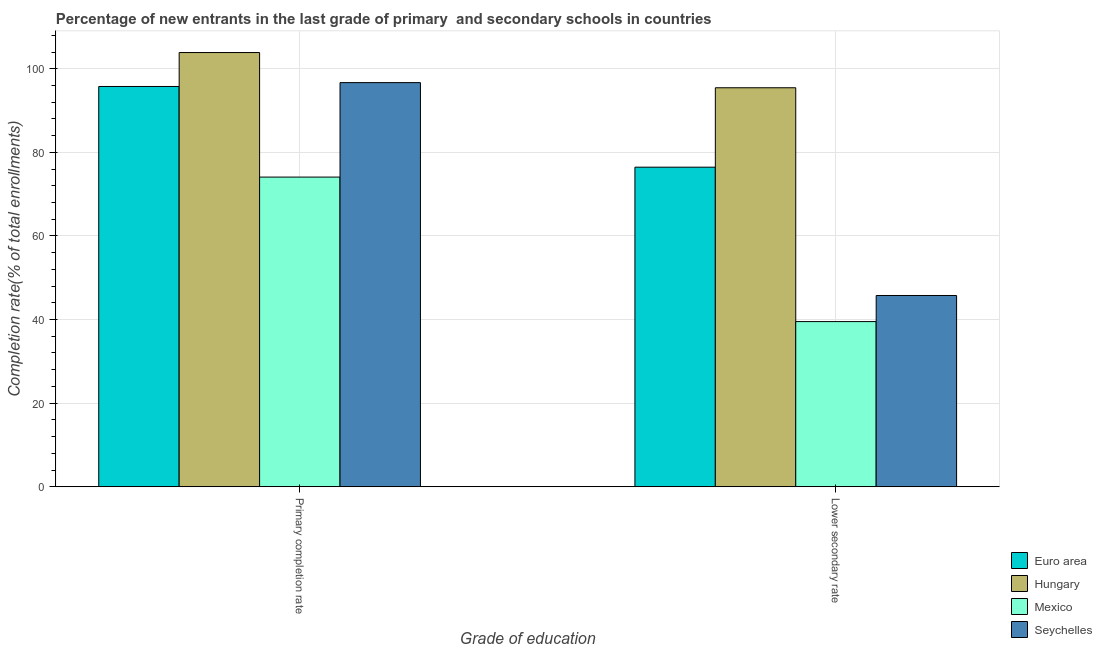How many different coloured bars are there?
Make the answer very short. 4. How many groups of bars are there?
Offer a very short reply. 2. Are the number of bars per tick equal to the number of legend labels?
Your response must be concise. Yes. Are the number of bars on each tick of the X-axis equal?
Make the answer very short. Yes. What is the label of the 1st group of bars from the left?
Your answer should be compact. Primary completion rate. What is the completion rate in secondary schools in Hungary?
Provide a succinct answer. 95.45. Across all countries, what is the maximum completion rate in primary schools?
Your response must be concise. 103.88. Across all countries, what is the minimum completion rate in primary schools?
Your answer should be compact. 74.08. In which country was the completion rate in primary schools maximum?
Give a very brief answer. Hungary. In which country was the completion rate in primary schools minimum?
Offer a terse response. Mexico. What is the total completion rate in primary schools in the graph?
Provide a short and direct response. 370.4. What is the difference between the completion rate in primary schools in Hungary and that in Seychelles?
Make the answer very short. 7.2. What is the difference between the completion rate in primary schools in Hungary and the completion rate in secondary schools in Seychelles?
Provide a short and direct response. 58.13. What is the average completion rate in primary schools per country?
Keep it short and to the point. 92.6. What is the difference between the completion rate in primary schools and completion rate in secondary schools in Mexico?
Your answer should be compact. 34.57. What is the ratio of the completion rate in secondary schools in Mexico to that in Hungary?
Give a very brief answer. 0.41. In how many countries, is the completion rate in primary schools greater than the average completion rate in primary schools taken over all countries?
Offer a very short reply. 3. What does the 4th bar from the left in Lower secondary rate represents?
Provide a short and direct response. Seychelles. What does the 2nd bar from the right in Lower secondary rate represents?
Make the answer very short. Mexico. How many bars are there?
Offer a terse response. 8. Are all the bars in the graph horizontal?
Your response must be concise. No. Does the graph contain grids?
Give a very brief answer. Yes. How are the legend labels stacked?
Your answer should be compact. Vertical. What is the title of the graph?
Ensure brevity in your answer.  Percentage of new entrants in the last grade of primary  and secondary schools in countries. What is the label or title of the X-axis?
Ensure brevity in your answer.  Grade of education. What is the label or title of the Y-axis?
Offer a terse response. Completion rate(% of total enrollments). What is the Completion rate(% of total enrollments) of Euro area in Primary completion rate?
Provide a succinct answer. 95.76. What is the Completion rate(% of total enrollments) in Hungary in Primary completion rate?
Your answer should be compact. 103.88. What is the Completion rate(% of total enrollments) in Mexico in Primary completion rate?
Your response must be concise. 74.08. What is the Completion rate(% of total enrollments) of Seychelles in Primary completion rate?
Give a very brief answer. 96.68. What is the Completion rate(% of total enrollments) of Euro area in Lower secondary rate?
Your answer should be very brief. 76.45. What is the Completion rate(% of total enrollments) in Hungary in Lower secondary rate?
Offer a very short reply. 95.45. What is the Completion rate(% of total enrollments) of Mexico in Lower secondary rate?
Offer a very short reply. 39.51. What is the Completion rate(% of total enrollments) in Seychelles in Lower secondary rate?
Your response must be concise. 45.75. Across all Grade of education, what is the maximum Completion rate(% of total enrollments) in Euro area?
Your answer should be compact. 95.76. Across all Grade of education, what is the maximum Completion rate(% of total enrollments) of Hungary?
Provide a succinct answer. 103.88. Across all Grade of education, what is the maximum Completion rate(% of total enrollments) of Mexico?
Ensure brevity in your answer.  74.08. Across all Grade of education, what is the maximum Completion rate(% of total enrollments) of Seychelles?
Your response must be concise. 96.68. Across all Grade of education, what is the minimum Completion rate(% of total enrollments) in Euro area?
Offer a very short reply. 76.45. Across all Grade of education, what is the minimum Completion rate(% of total enrollments) in Hungary?
Your answer should be compact. 95.45. Across all Grade of education, what is the minimum Completion rate(% of total enrollments) of Mexico?
Provide a succinct answer. 39.51. Across all Grade of education, what is the minimum Completion rate(% of total enrollments) in Seychelles?
Your response must be concise. 45.75. What is the total Completion rate(% of total enrollments) of Euro area in the graph?
Ensure brevity in your answer.  172.21. What is the total Completion rate(% of total enrollments) of Hungary in the graph?
Provide a short and direct response. 199.34. What is the total Completion rate(% of total enrollments) of Mexico in the graph?
Your response must be concise. 113.59. What is the total Completion rate(% of total enrollments) of Seychelles in the graph?
Your answer should be very brief. 142.44. What is the difference between the Completion rate(% of total enrollments) of Euro area in Primary completion rate and that in Lower secondary rate?
Your answer should be very brief. 19.31. What is the difference between the Completion rate(% of total enrollments) in Hungary in Primary completion rate and that in Lower secondary rate?
Ensure brevity in your answer.  8.43. What is the difference between the Completion rate(% of total enrollments) of Mexico in Primary completion rate and that in Lower secondary rate?
Give a very brief answer. 34.57. What is the difference between the Completion rate(% of total enrollments) in Seychelles in Primary completion rate and that in Lower secondary rate?
Provide a succinct answer. 50.93. What is the difference between the Completion rate(% of total enrollments) of Euro area in Primary completion rate and the Completion rate(% of total enrollments) of Hungary in Lower secondary rate?
Your answer should be very brief. 0.3. What is the difference between the Completion rate(% of total enrollments) in Euro area in Primary completion rate and the Completion rate(% of total enrollments) in Mexico in Lower secondary rate?
Your response must be concise. 56.25. What is the difference between the Completion rate(% of total enrollments) of Euro area in Primary completion rate and the Completion rate(% of total enrollments) of Seychelles in Lower secondary rate?
Give a very brief answer. 50.01. What is the difference between the Completion rate(% of total enrollments) in Hungary in Primary completion rate and the Completion rate(% of total enrollments) in Mexico in Lower secondary rate?
Your answer should be very brief. 64.37. What is the difference between the Completion rate(% of total enrollments) in Hungary in Primary completion rate and the Completion rate(% of total enrollments) in Seychelles in Lower secondary rate?
Offer a very short reply. 58.13. What is the difference between the Completion rate(% of total enrollments) in Mexico in Primary completion rate and the Completion rate(% of total enrollments) in Seychelles in Lower secondary rate?
Make the answer very short. 28.33. What is the average Completion rate(% of total enrollments) of Euro area per Grade of education?
Give a very brief answer. 86.11. What is the average Completion rate(% of total enrollments) of Hungary per Grade of education?
Give a very brief answer. 99.67. What is the average Completion rate(% of total enrollments) of Mexico per Grade of education?
Provide a succinct answer. 56.79. What is the average Completion rate(% of total enrollments) in Seychelles per Grade of education?
Your answer should be compact. 71.22. What is the difference between the Completion rate(% of total enrollments) in Euro area and Completion rate(% of total enrollments) in Hungary in Primary completion rate?
Your answer should be very brief. -8.12. What is the difference between the Completion rate(% of total enrollments) of Euro area and Completion rate(% of total enrollments) of Mexico in Primary completion rate?
Offer a very short reply. 21.68. What is the difference between the Completion rate(% of total enrollments) of Euro area and Completion rate(% of total enrollments) of Seychelles in Primary completion rate?
Your response must be concise. -0.92. What is the difference between the Completion rate(% of total enrollments) of Hungary and Completion rate(% of total enrollments) of Mexico in Primary completion rate?
Your answer should be very brief. 29.8. What is the difference between the Completion rate(% of total enrollments) in Hungary and Completion rate(% of total enrollments) in Seychelles in Primary completion rate?
Your answer should be very brief. 7.2. What is the difference between the Completion rate(% of total enrollments) in Mexico and Completion rate(% of total enrollments) in Seychelles in Primary completion rate?
Your response must be concise. -22.6. What is the difference between the Completion rate(% of total enrollments) of Euro area and Completion rate(% of total enrollments) of Hungary in Lower secondary rate?
Offer a very short reply. -19. What is the difference between the Completion rate(% of total enrollments) in Euro area and Completion rate(% of total enrollments) in Mexico in Lower secondary rate?
Your answer should be compact. 36.95. What is the difference between the Completion rate(% of total enrollments) of Euro area and Completion rate(% of total enrollments) of Seychelles in Lower secondary rate?
Give a very brief answer. 30.7. What is the difference between the Completion rate(% of total enrollments) in Hungary and Completion rate(% of total enrollments) in Mexico in Lower secondary rate?
Your response must be concise. 55.95. What is the difference between the Completion rate(% of total enrollments) of Hungary and Completion rate(% of total enrollments) of Seychelles in Lower secondary rate?
Provide a succinct answer. 49.7. What is the difference between the Completion rate(% of total enrollments) in Mexico and Completion rate(% of total enrollments) in Seychelles in Lower secondary rate?
Provide a succinct answer. -6.25. What is the ratio of the Completion rate(% of total enrollments) of Euro area in Primary completion rate to that in Lower secondary rate?
Make the answer very short. 1.25. What is the ratio of the Completion rate(% of total enrollments) in Hungary in Primary completion rate to that in Lower secondary rate?
Your response must be concise. 1.09. What is the ratio of the Completion rate(% of total enrollments) of Mexico in Primary completion rate to that in Lower secondary rate?
Keep it short and to the point. 1.88. What is the ratio of the Completion rate(% of total enrollments) in Seychelles in Primary completion rate to that in Lower secondary rate?
Offer a terse response. 2.11. What is the difference between the highest and the second highest Completion rate(% of total enrollments) in Euro area?
Keep it short and to the point. 19.31. What is the difference between the highest and the second highest Completion rate(% of total enrollments) in Hungary?
Ensure brevity in your answer.  8.43. What is the difference between the highest and the second highest Completion rate(% of total enrollments) of Mexico?
Make the answer very short. 34.57. What is the difference between the highest and the second highest Completion rate(% of total enrollments) of Seychelles?
Make the answer very short. 50.93. What is the difference between the highest and the lowest Completion rate(% of total enrollments) of Euro area?
Ensure brevity in your answer.  19.31. What is the difference between the highest and the lowest Completion rate(% of total enrollments) of Hungary?
Give a very brief answer. 8.43. What is the difference between the highest and the lowest Completion rate(% of total enrollments) of Mexico?
Provide a succinct answer. 34.57. What is the difference between the highest and the lowest Completion rate(% of total enrollments) in Seychelles?
Provide a succinct answer. 50.93. 